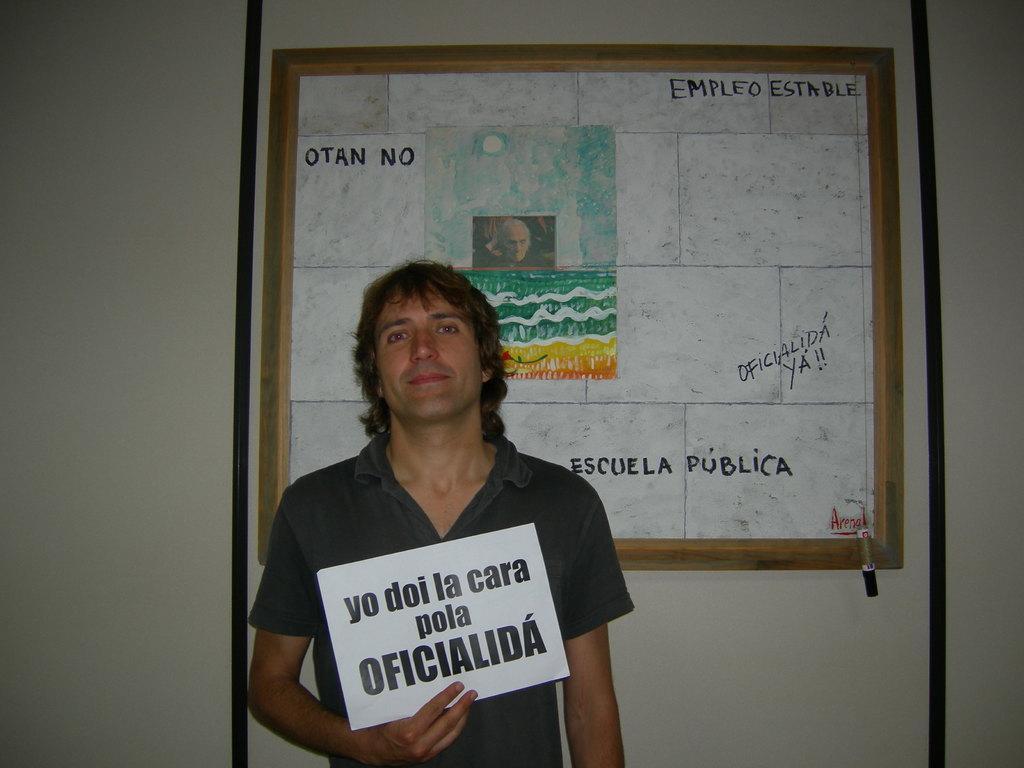Describe this image in one or two sentences. There is a person in gray color t-shirt smiling, standing and holding a white color hoarding. In the background, there is a board which is attached to the wall. 